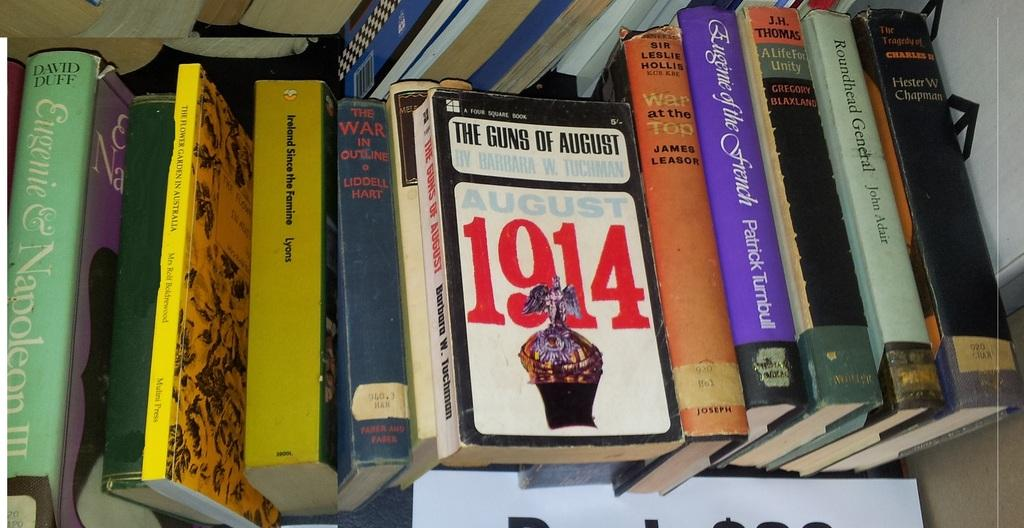What is the main subject of the image? The main subject of the image is a zoomed in picture of books. Can you describe any specific details about the books? Yes, there are names on the books. How does the sand affect the grip of the books in the image? There is no sand present in the image, so it cannot affect the grip of the books. 